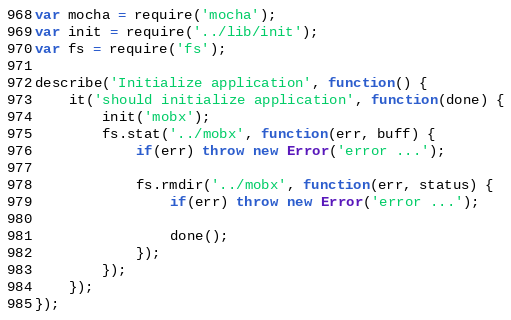<code> <loc_0><loc_0><loc_500><loc_500><_JavaScript_>var mocha = require('mocha');
var init = require('../lib/init');
var fs = require('fs');

describe('Initialize application', function() {
    it('should initialize application', function(done) {
    	init('mobx');
    	fs.stat('../mobx', function(err, buff) {
    		if(err) throw new Error('error ...');
    		
    		fs.rmdir('../mobx', function(err, status) {
    			if(err) throw new Error('error ...');

    			done();
    		});
    	});
    });
});</code> 